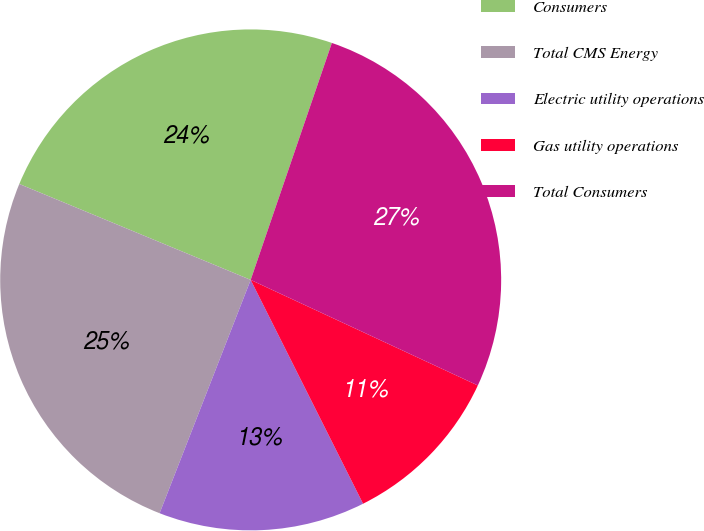Convert chart. <chart><loc_0><loc_0><loc_500><loc_500><pie_chart><fcel>Consumers<fcel>Total CMS Energy<fcel>Electric utility operations<fcel>Gas utility operations<fcel>Total Consumers<nl><fcel>24.0%<fcel>25.33%<fcel>13.33%<fcel>10.67%<fcel>26.67%<nl></chart> 